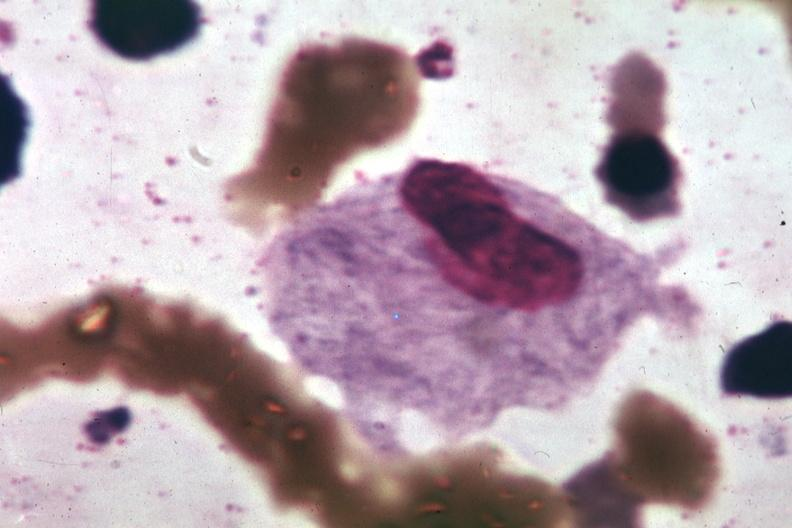s hematologic present?
Answer the question using a single word or phrase. Yes 